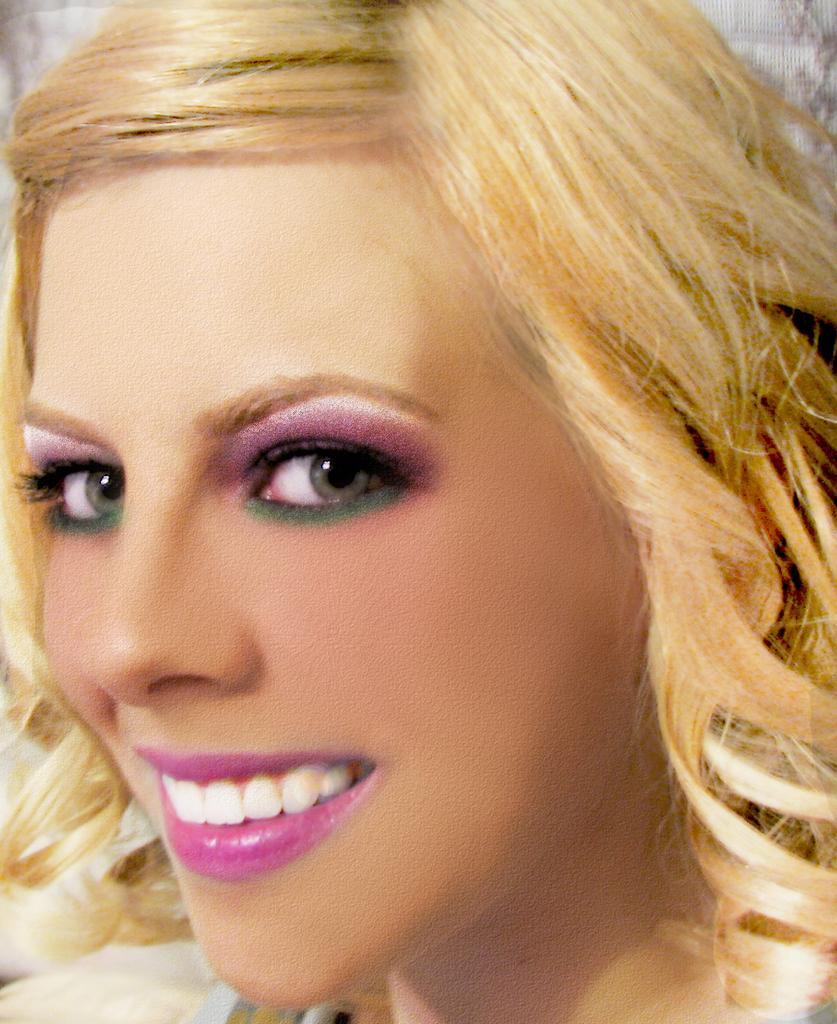Could you give a brief overview of what you see in this image? In this picture we can see a lady face. 